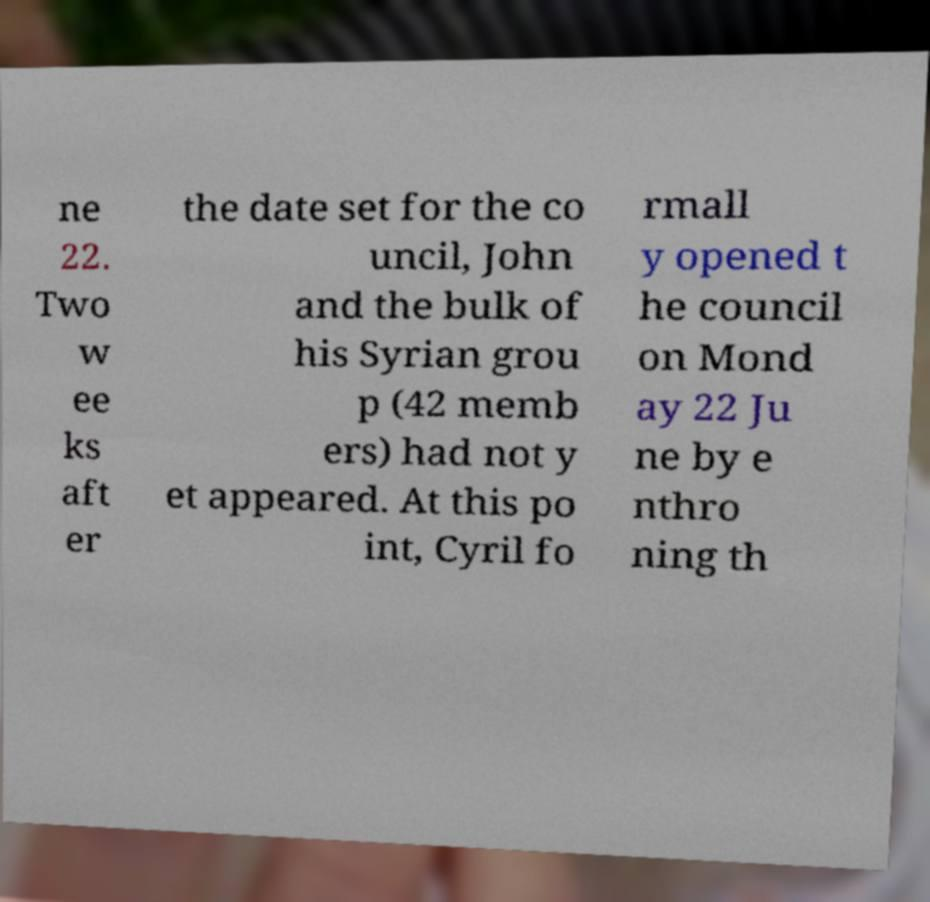What messages or text are displayed in this image? I need them in a readable, typed format. ne 22. Two w ee ks aft er the date set for the co uncil, John and the bulk of his Syrian grou p (42 memb ers) had not y et appeared. At this po int, Cyril fo rmall y opened t he council on Mond ay 22 Ju ne by e nthro ning th 